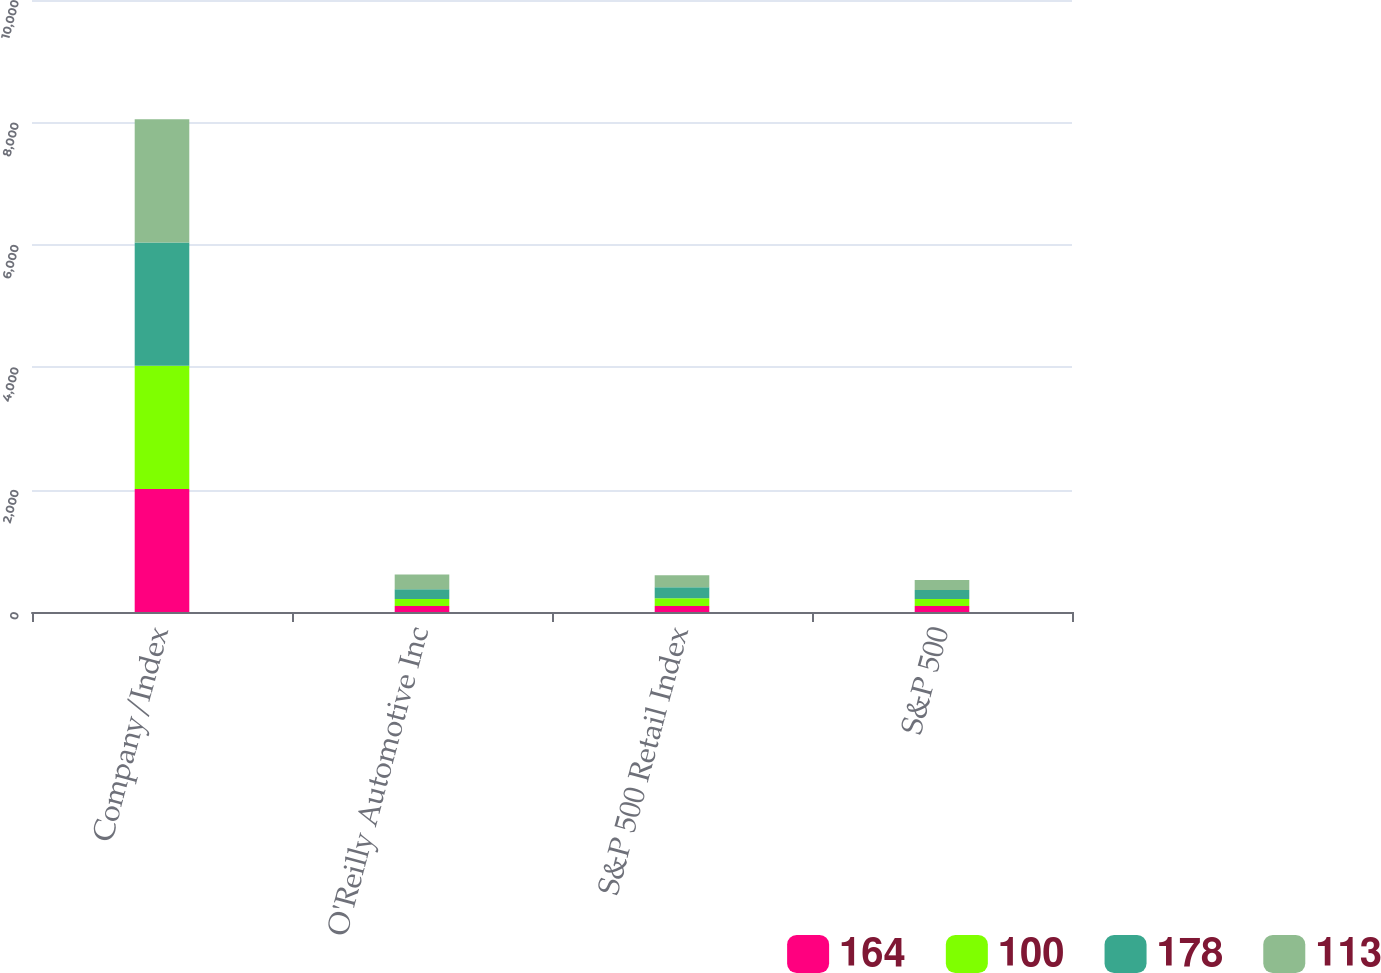<chart> <loc_0><loc_0><loc_500><loc_500><stacked_bar_chart><ecel><fcel>Company/Index<fcel>O'Reilly Automotive Inc<fcel>S&P 500 Retail Index<fcel>S&P 500<nl><fcel>164<fcel>2011<fcel>100<fcel>100<fcel>100<nl><fcel>100<fcel>2012<fcel>112<fcel>125<fcel>113<nl><fcel>178<fcel>2013<fcel>161<fcel>180<fcel>147<nl><fcel>113<fcel>2014<fcel>241<fcel>197<fcel>164<nl></chart> 